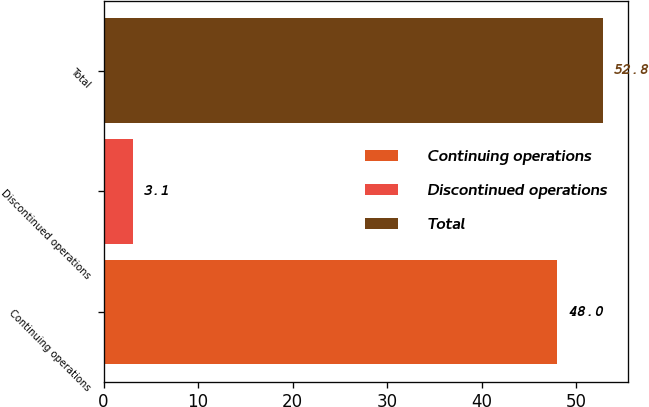Convert chart to OTSL. <chart><loc_0><loc_0><loc_500><loc_500><bar_chart><fcel>Continuing operations<fcel>Discontinued operations<fcel>Total<nl><fcel>48<fcel>3.1<fcel>52.8<nl></chart> 